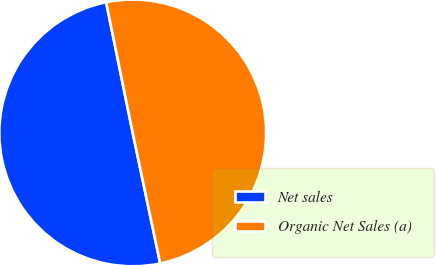<chart> <loc_0><loc_0><loc_500><loc_500><pie_chart><fcel>Net sales<fcel>Organic Net Sales (a)<nl><fcel>50.11%<fcel>49.89%<nl></chart> 